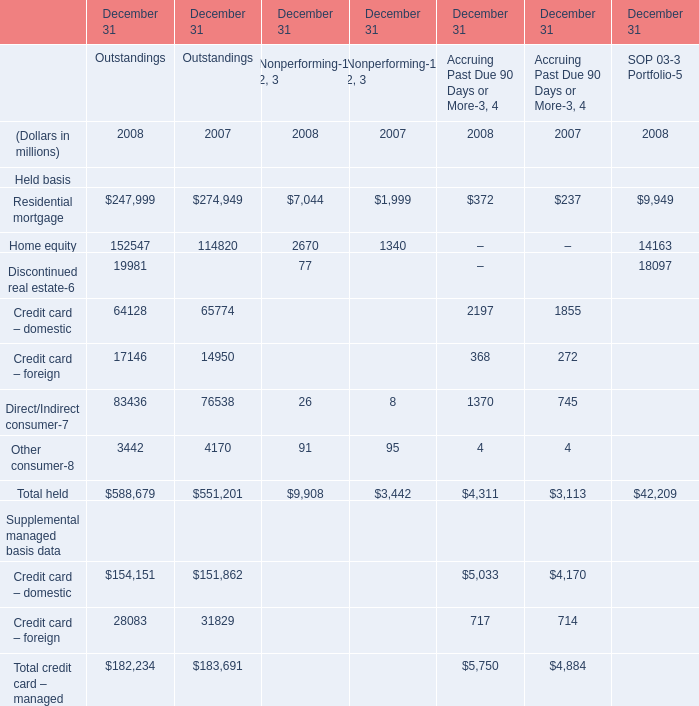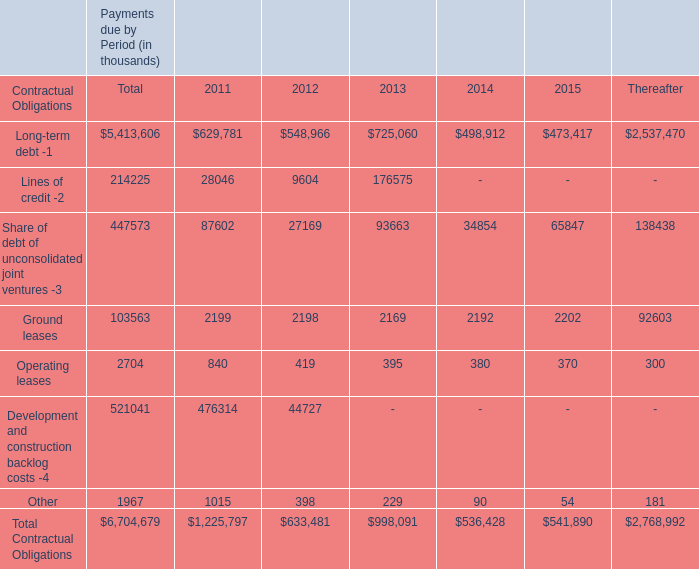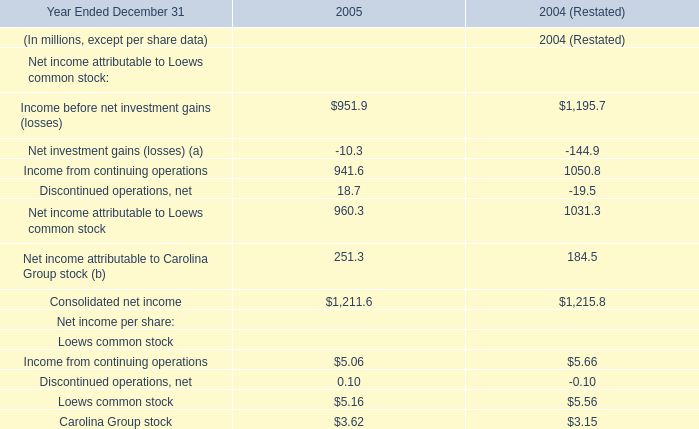What's the average of Residential mortgage and Home equity in 2008? (in million) 
Computations: ((247999 + 152547) / 2)
Answer: 200273.0. 